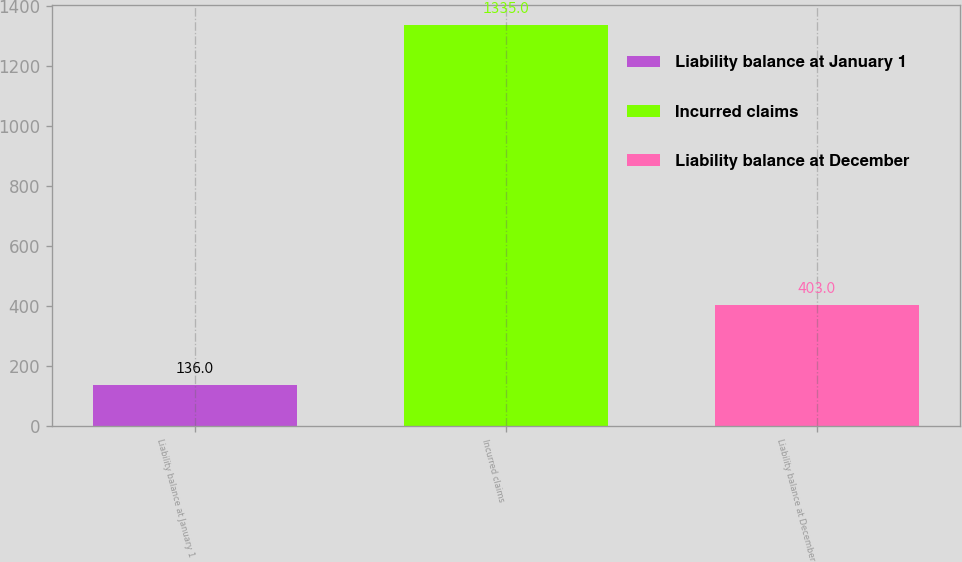Convert chart to OTSL. <chart><loc_0><loc_0><loc_500><loc_500><bar_chart><fcel>Liability balance at January 1<fcel>Incurred claims<fcel>Liability balance at December<nl><fcel>136<fcel>1335<fcel>403<nl></chart> 